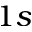<formula> <loc_0><loc_0><loc_500><loc_500>1 s</formula> 